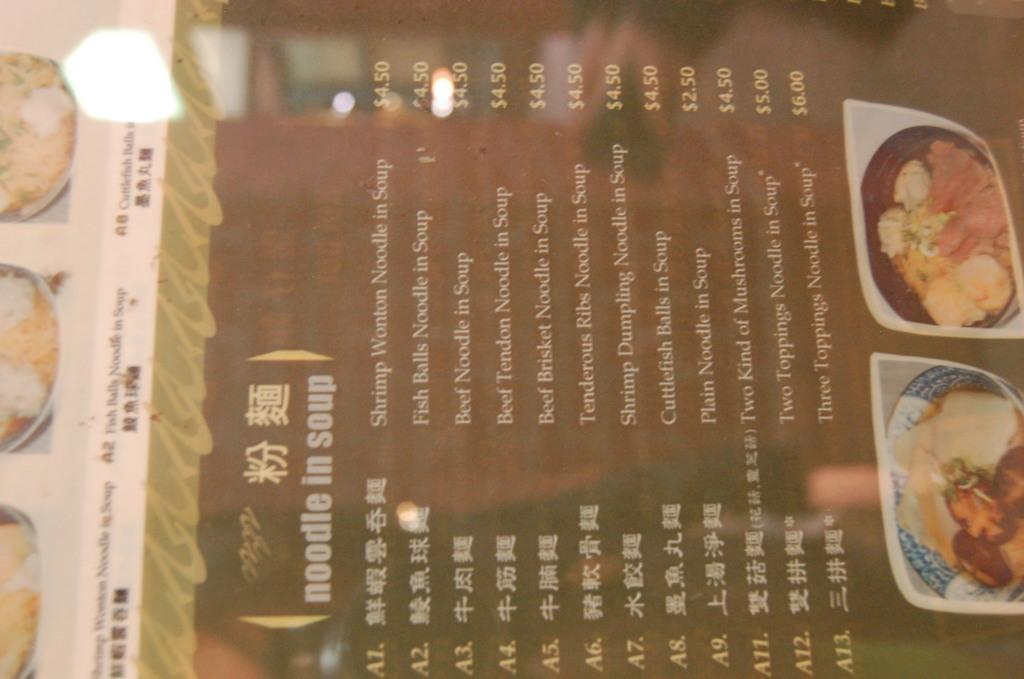What is the main object in the image? There is a menu card in the image. What information can be found on the menu card? The menu card contains dish names and price details. Who is the writer of the menu card in the image? There is no information about the writer of the menu card in the image. 